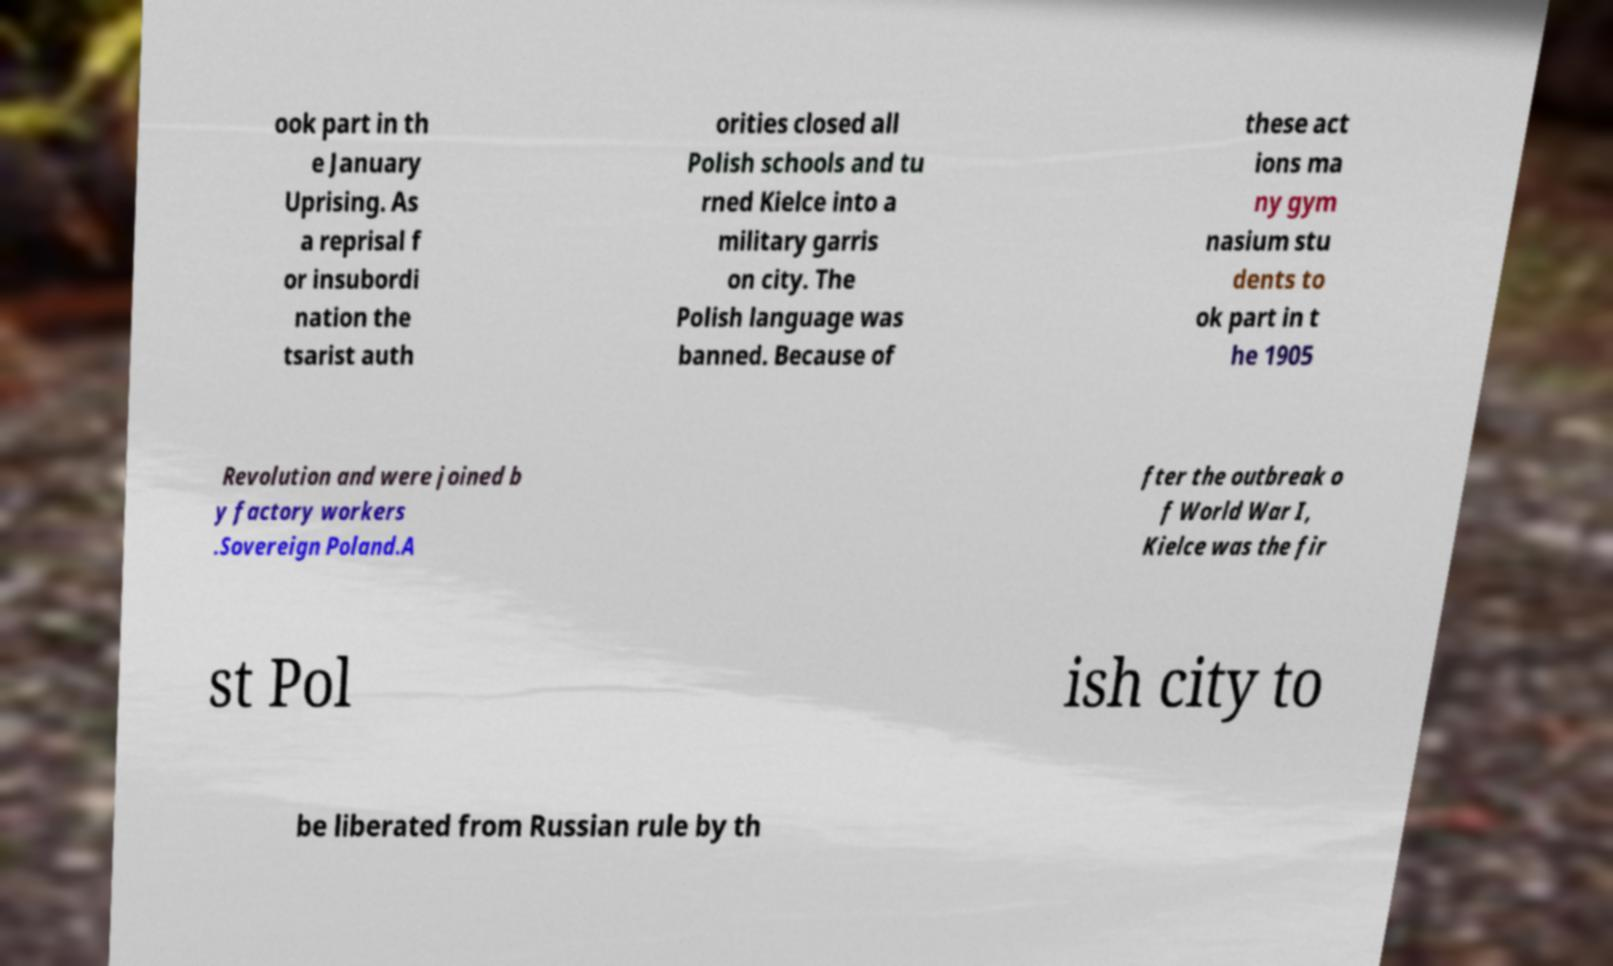What messages or text are displayed in this image? I need them in a readable, typed format. ook part in th e January Uprising. As a reprisal f or insubordi nation the tsarist auth orities closed all Polish schools and tu rned Kielce into a military garris on city. The Polish language was banned. Because of these act ions ma ny gym nasium stu dents to ok part in t he 1905 Revolution and were joined b y factory workers .Sovereign Poland.A fter the outbreak o f World War I, Kielce was the fir st Pol ish city to be liberated from Russian rule by th 